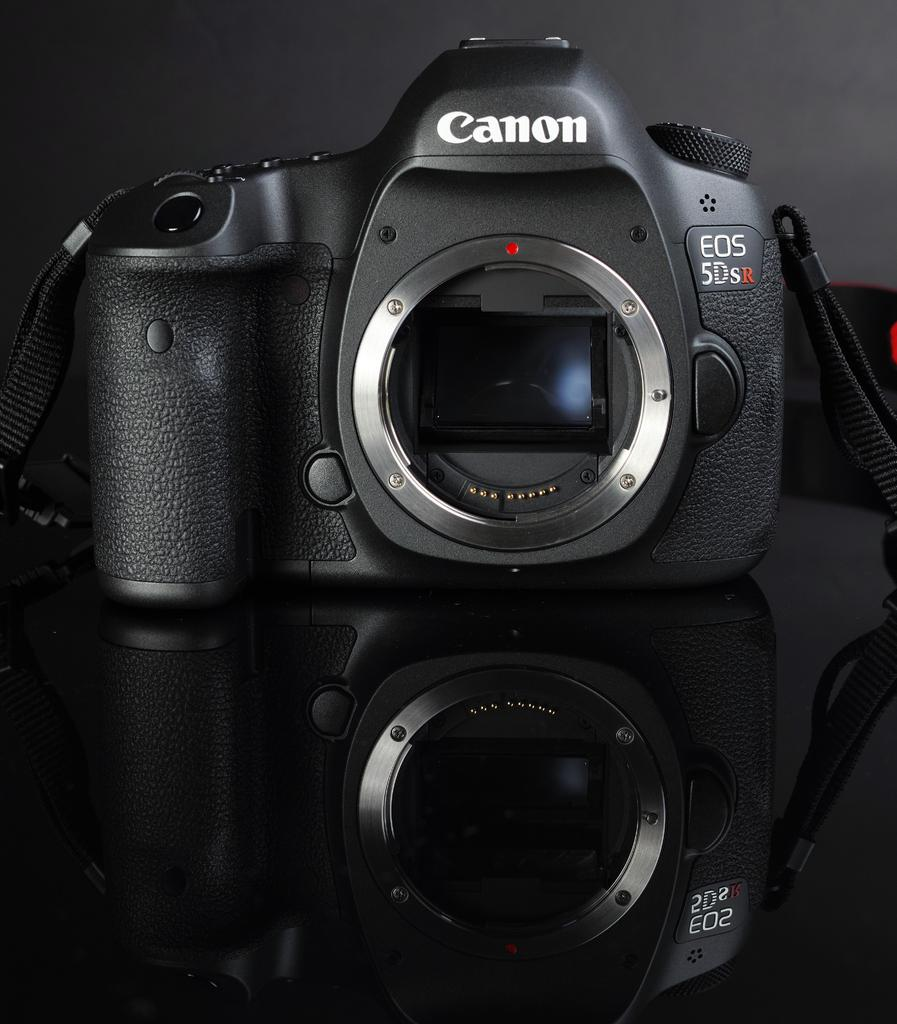<image>
Create a compact narrative representing the image presented. The camera here is the Canon model EOS 5Dsr. 